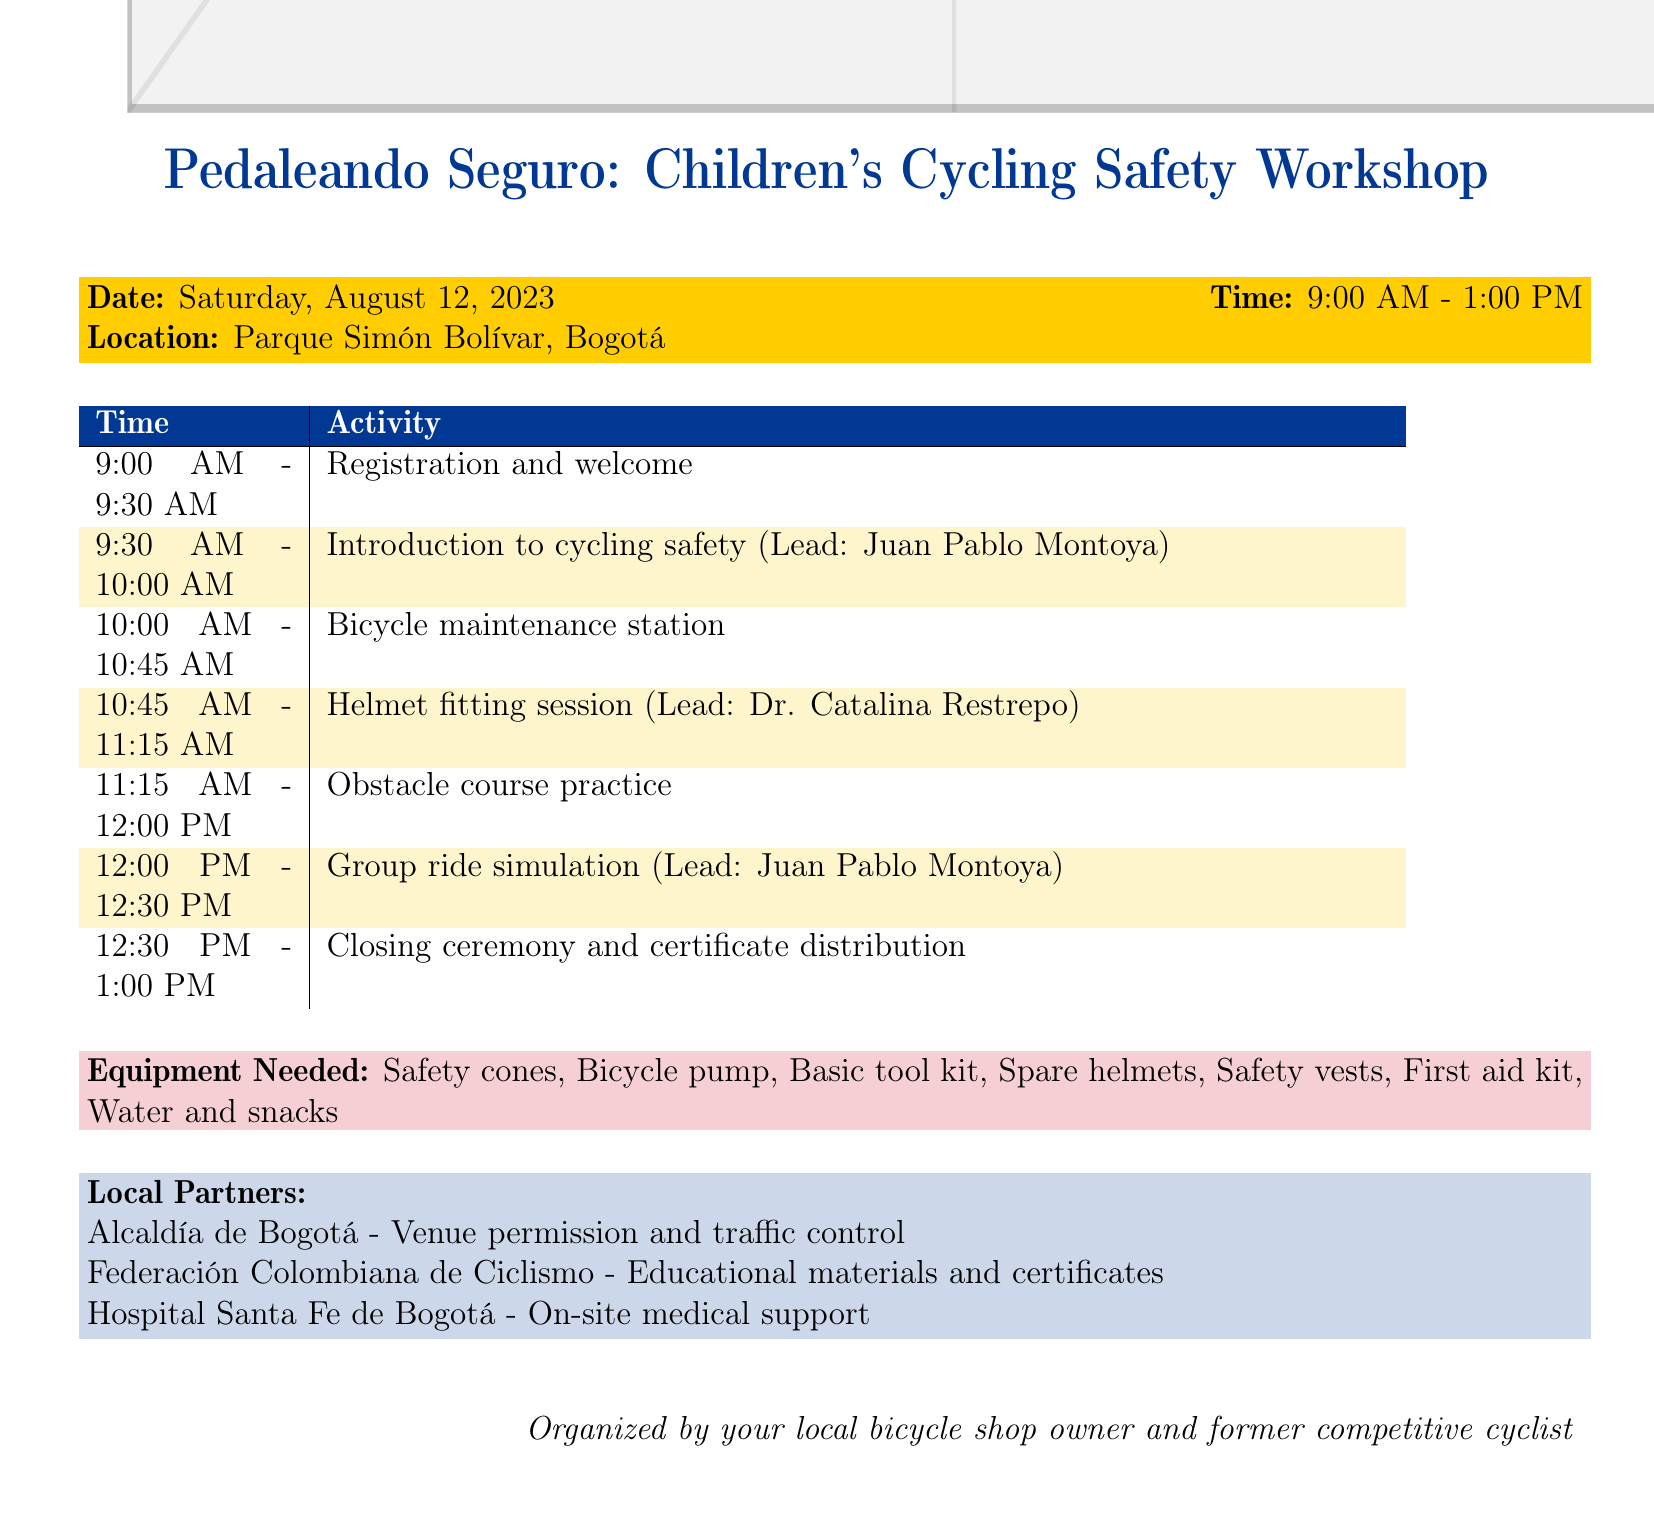What is the title of the workshop? The title of the workshop is explicitly stated in the document under "workshop_details".
Answer: Pedaleando Seguro: Children's Cycling Safety Workshop What is the date of the workshop? The date is clearly mentioned in the "workshop_details" section.
Answer: Saturday, August 12, 2023 Who is leading the introduction to cycling safety? The leader for this segment is identified in the corresponding agenda item.
Answer: Juan Pablo Montoya What activity is scheduled from 10:45 AM to 11:15 AM? The activity is specified in the agenda timing for that period.
Answer: Helmet fitting session How many volunteers are assigned to the obstacle course practice? The number of volunteers is detailed in the respective agenda item description.
Answer: Three What equipment is needed for the workshop? The list of required equipment is provided in the document.
Answer: Safety cones, Bicycle pump, Basic tool kit, Spare helmets, Safety vests, First aid kit, Bottled water and snacks What is one of the post-event activities planned? The document lists several activities after the event, highlighting future engagement.
Answer: Collect feedback from participants and volunteers Which organization is responsible for on-site medical support? The contribution by local partners includes specific responsibilities.
Answer: Hospital Santa Fe de Bogotá What time is the closing ceremony scheduled? The closing timing is mentioned in the agenda, indicating the last activity time.
Answer: 12:30 PM - 1:00 PM 